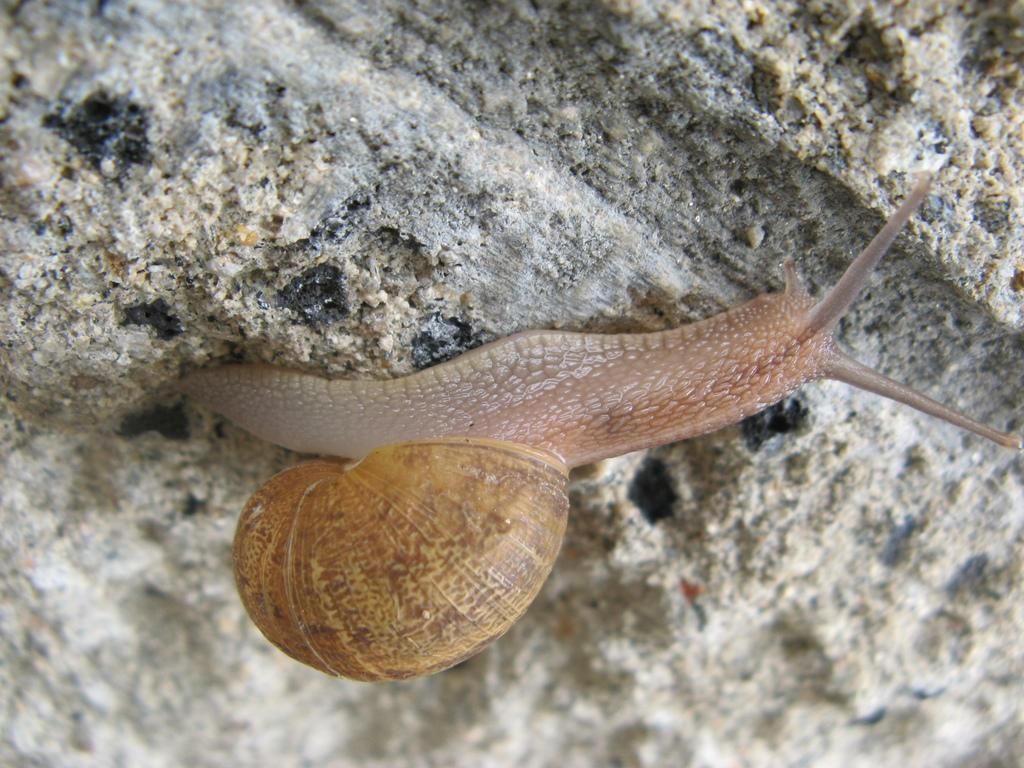What type of animal is in the picture? There is a snail in the picture. What color is the snail? The snail is brown in color. What surface is the snail crawling on? The snail is crawling on a surface that resembles a stone. How many girls are present in the picture? There are no girls present in the picture; it features a snail crawling on a stone surface. Is the snail's journey affected by the rain in the picture? There is no rain present in the picture, and therefore it cannot affect the snail's journey. 